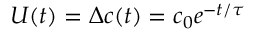Convert formula to latex. <formula><loc_0><loc_0><loc_500><loc_500>U ( t ) = \Delta c ( t ) = c _ { 0 } e ^ { - t / \tau }</formula> 